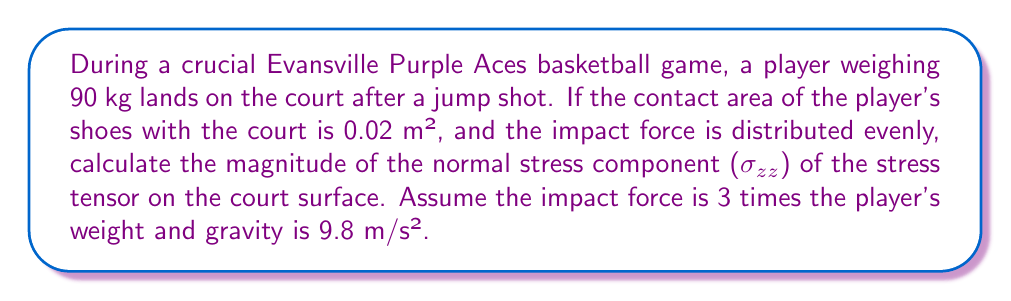Provide a solution to this math problem. Let's approach this step-by-step:

1) First, we need to calculate the player's weight:
   $W = mg = 90 \text{ kg} \times 9.8 \text{ m/s²} = 882 \text{ N}$

2) The impact force is 3 times the player's weight:
   $F_{\text{impact}} = 3W = 3 \times 882 \text{ N} = 2646 \text{ N}$

3) The stress tensor for a normal force on a surface is given by:

   $$\sigma_{ij} = \begin{pmatrix}
   0 & 0 & 0 \\
   0 & 0 & 0 \\
   0 & 0 & \sigma_{zz}
   \end{pmatrix}$$

   Where $\sigma_{zz}$ is the normal stress in the z-direction (perpendicular to the court surface).

4) The normal stress $\sigma_{zz}$ is calculated by dividing the force by the area:

   $$\sigma_{zz} = \frac{F_{\text{impact}}}{A}$$

5) Substituting the values:

   $$\sigma_{zz} = \frac{2646 \text{ N}}{0.02 \text{ m²}} = 132300 \text{ N/m²} = 132.3 \text{ kPa}$$

Therefore, the magnitude of the normal stress component ($\sigma_{zz}$) of the stress tensor on the court surface is 132.3 kPa.
Answer: 132.3 kPa 